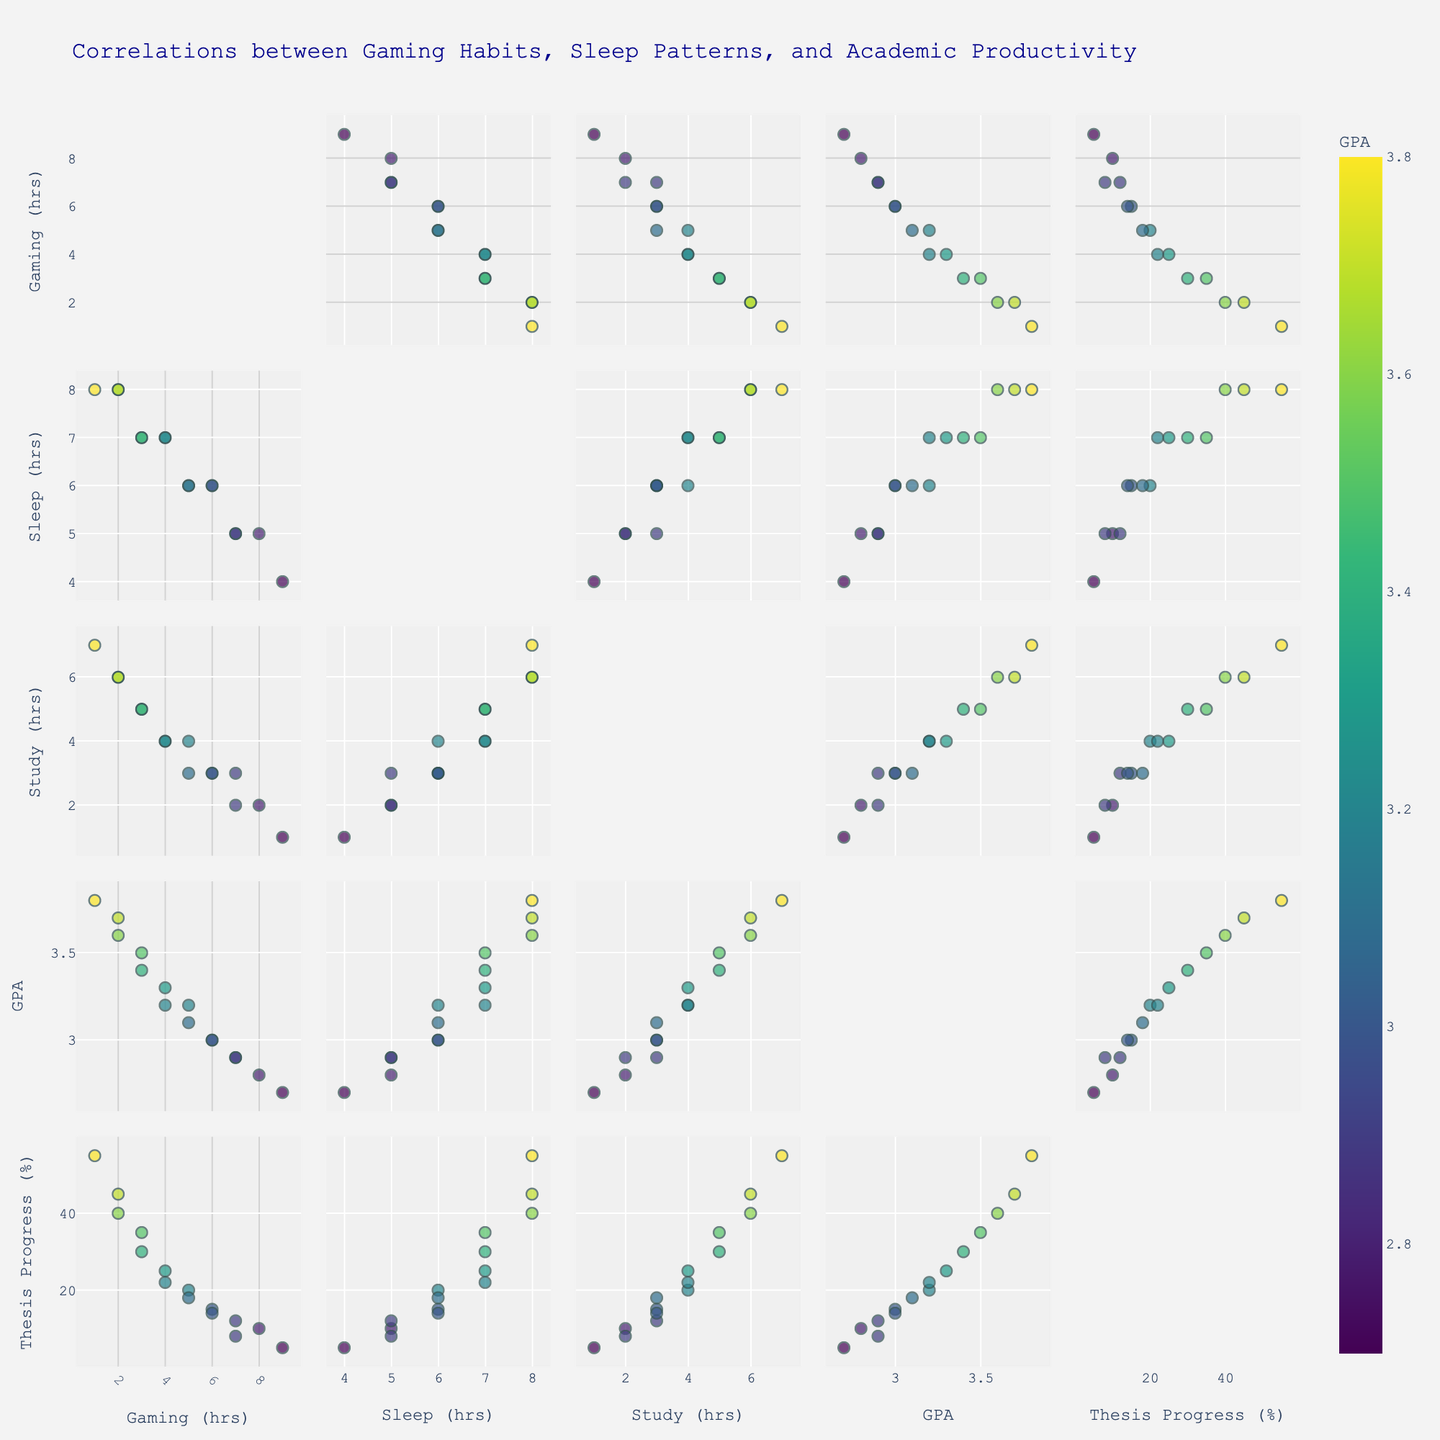What is the title of the scatterplot matrix? Look at the top center of the scatterplot matrix to find the title.
Answer: Correlations between Gaming Habits, Sleep Patterns, and Academic Productivity How many dimensions are represented in the scatterplot matrix? Count the number of variables shown along the rows and columns of the matrix.
Answer: 5 What color scale is used to represent the GPA in the scatterplot matrix? Observe the legend or color bar on the scatterplot matrix to determine the color scale.
Answer: Viridis Which variable seems to have the highest correlation with Study Hours? Compare the diagonal scatter plots for Study Hours against other variables and look for the strongest trend (straight line).
Answer: Thesis Progress What is the relationship between Hours_Gaming and Sleep_Duration? Examine the scatter plot where Hours_Gaming and Sleep_Duration intersect and describe the trend.
Answer: Negative correlation What does a darker dot represent in the scatterplot matrix? Interpret the color scale associated with GPA. Darker colors often represent lower or higher values in the chosen scale.
Answer: Higher GPA Which variable has the lowest correlation with Hours_Gaming? Check the scatter plots related to Hours_Gaming and identify the plot with the least discernible pattern.
Answer: GPA How many data points are shown in the scatterplot matrix? Count the total number of data points across any plot in the matrix; typically, this number remains constant.
Answer: 15 What is the GPA for someone who has 8 hours of Thesis Progress? Look for the data point where Thesis Progress is 8 and refer to its color according to the GPA scale.
Answer: 2.9 Is there a positive or negative correlation between Sleep_Duration and GPA? Examine the scatter plot for Sleep_Duration versus GPA to determine the correlation direction.
Answer: Positive correlation 